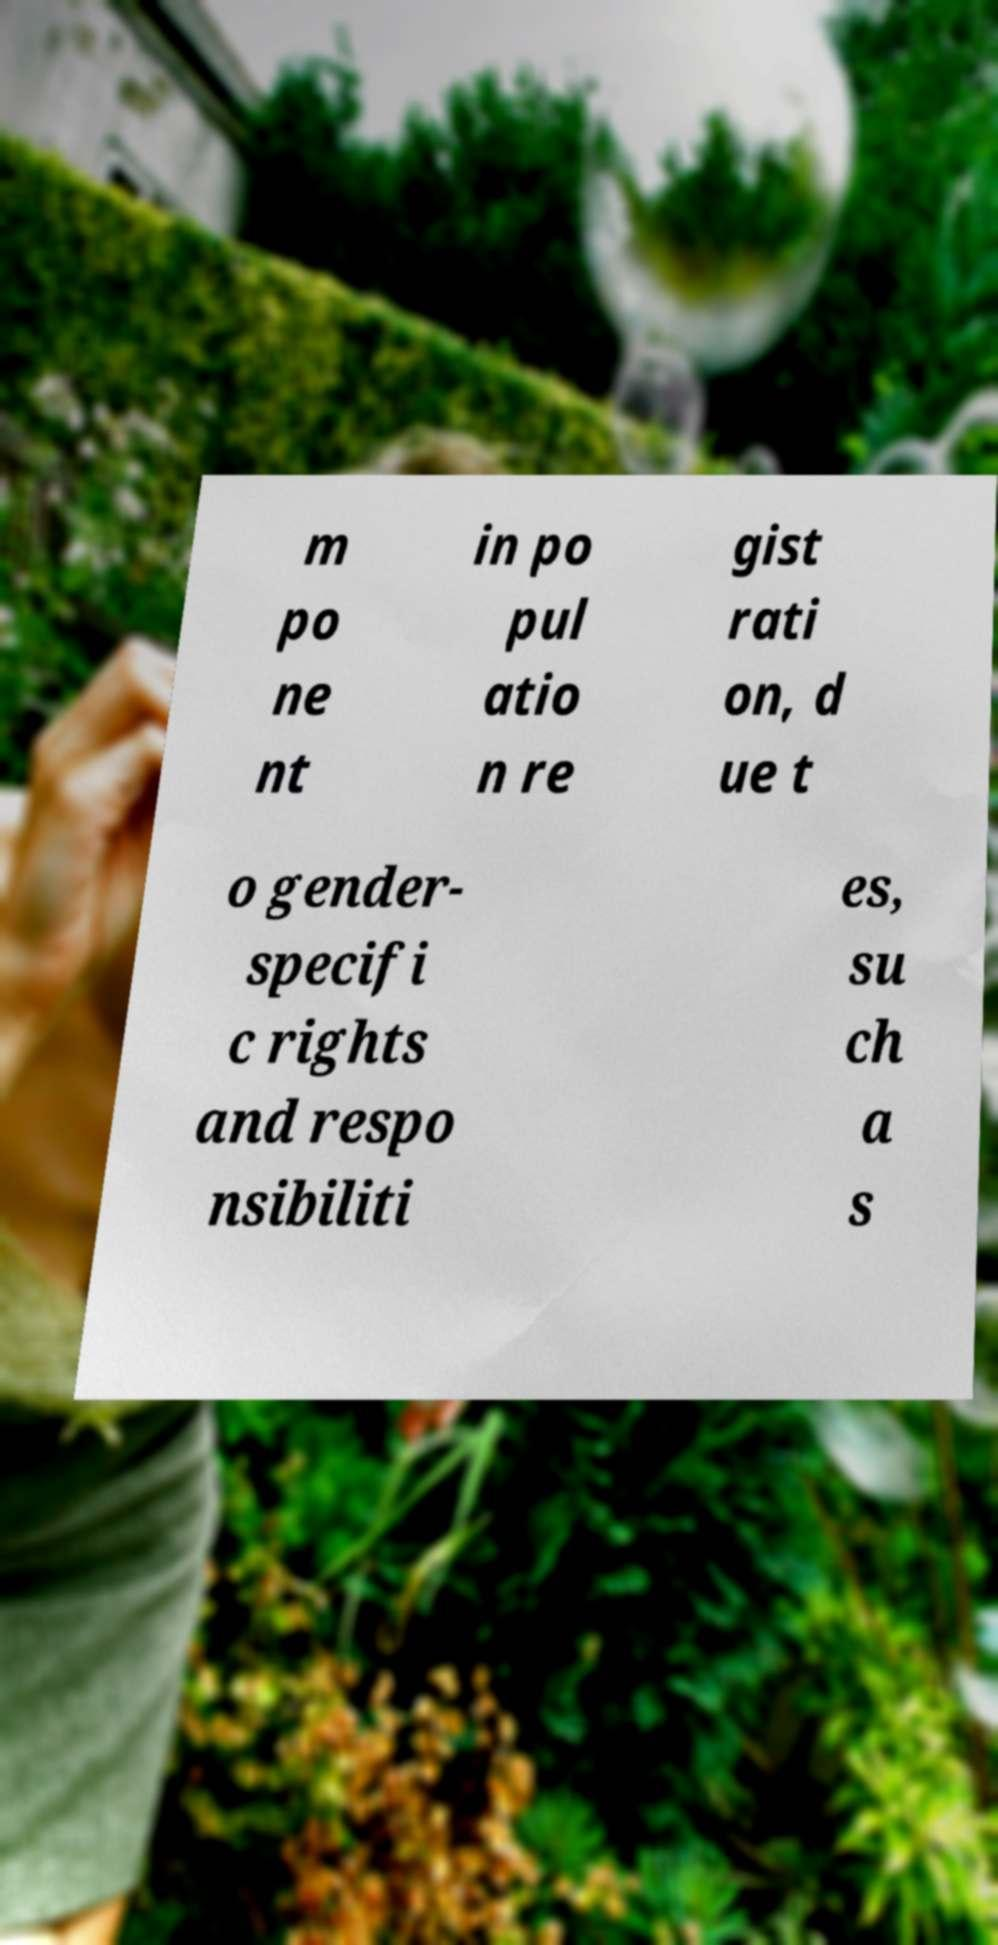Can you accurately transcribe the text from the provided image for me? m po ne nt in po pul atio n re gist rati on, d ue t o gender- specifi c rights and respo nsibiliti es, su ch a s 